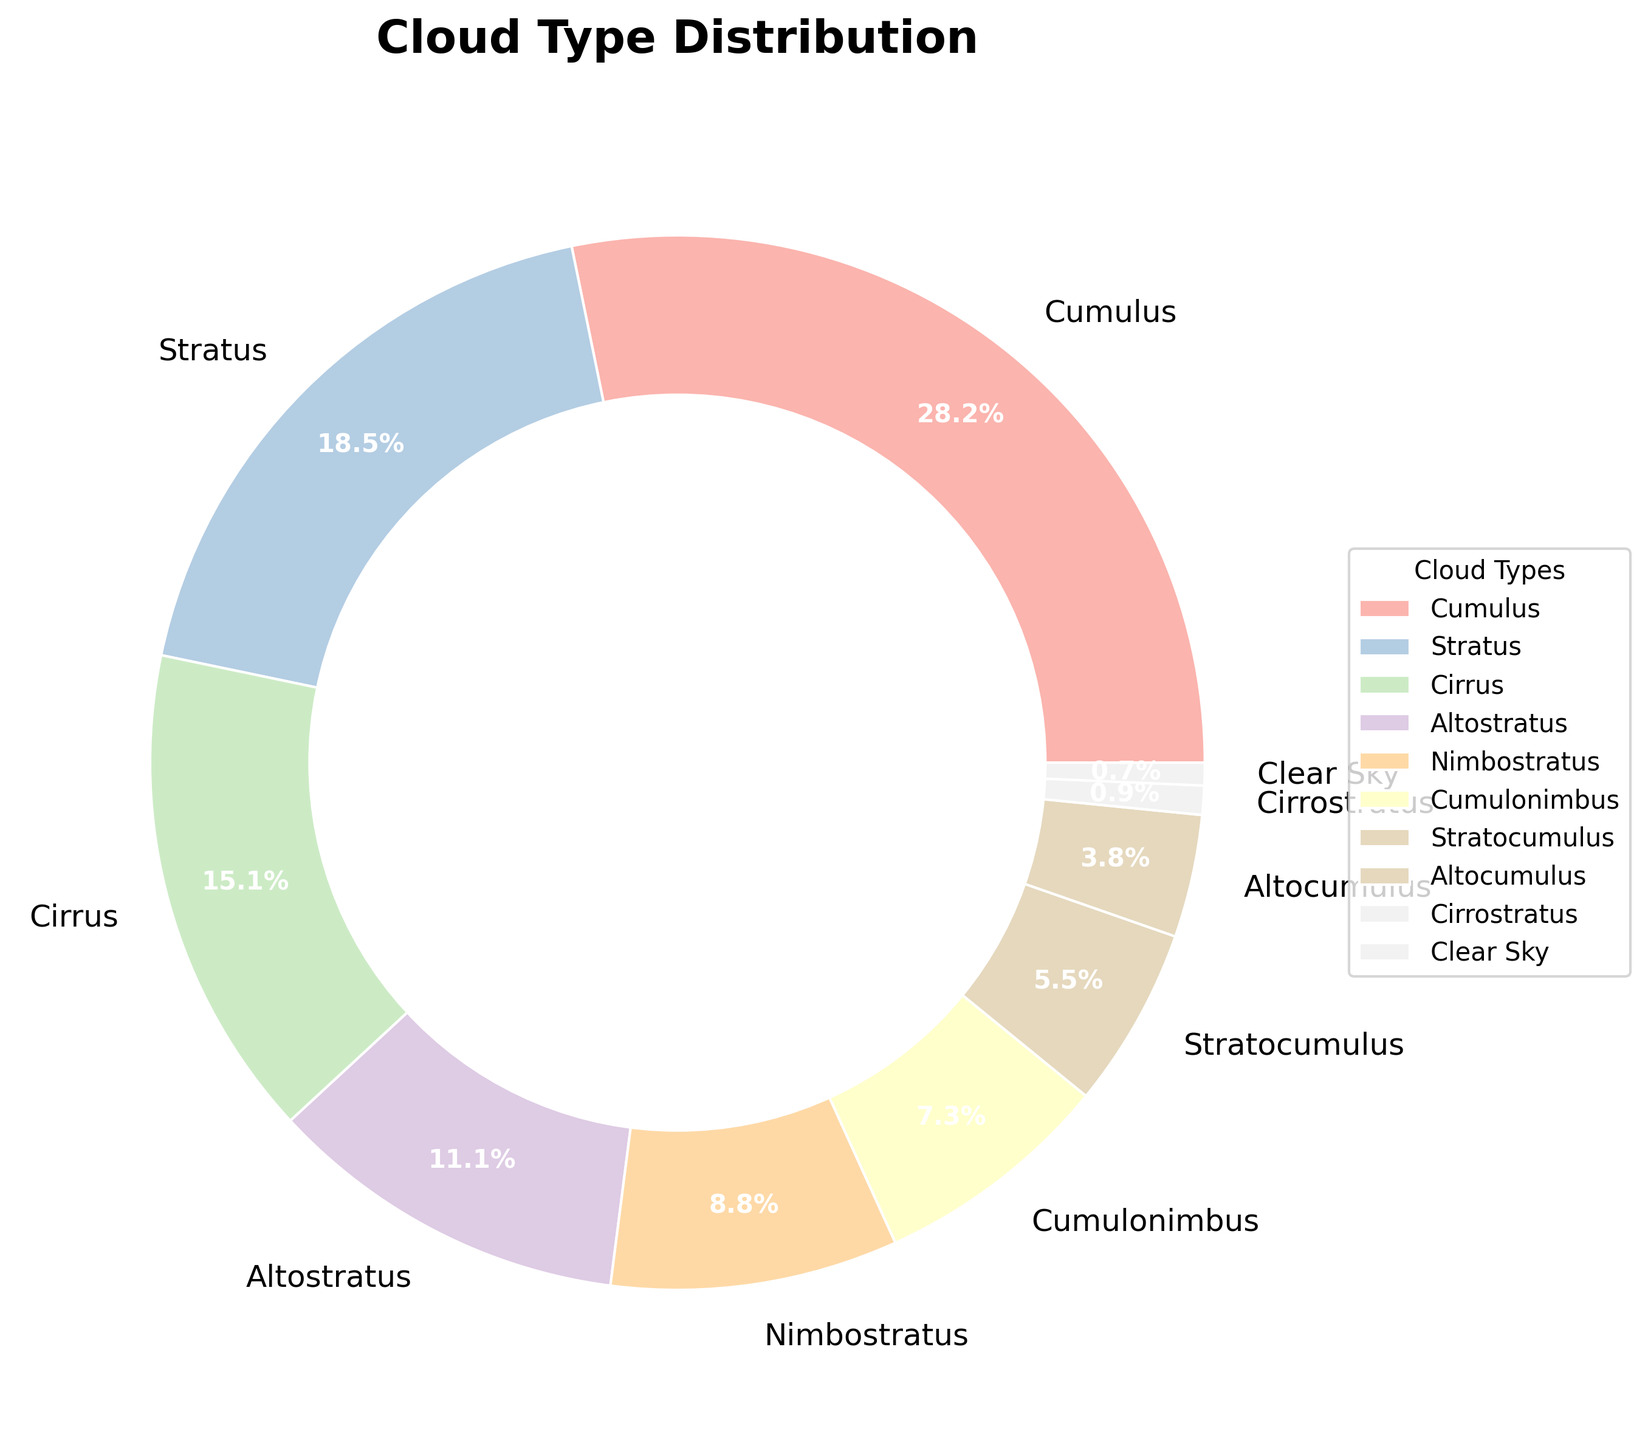What is the most common cloud type observed? By looking at the pie chart, we can see the largest section. The label with the highest percentage is "Cumulus" at 28.5%.
Answer: Cumulus Which cloud types comprise less than 10% each? From the chart, we can identify sections that are smaller than 10% by their corresponding labels. These are Nimbostratus (8.9%), Cumulonimbus (7.4%), Stratocumulus (5.6%), Altocumulus (3.8%), Cirrostratus (0.9%), and Clear Sky (0.7%).
Answer: Nimbostratus, Cumulonimbus, Stratocumulus, Altocumulus, Cirrostratus, Clear Sky How much more prevalent is Cumulus compared to Stratus clouds? Cumulus is at 28.5%, whereas Stratus is at 18.7%. The difference is calculated as 28.5% - 18.7%, which gives us 9.8%.
Answer: 9.8% Which cloud type is the least common, and what is its percentage? The smallest section in the pie chart is "Clear Sky," which has a percentage of 0.7%.
Answer: Clear Sky, 0.7% Are there more Altostratus or Altocumulus clouds observed? By comparing the two sections labeled Altostratus and Altocumulus, Altostratus is at 11.2%, while Altocumulus is at 3.8%. Therefore, Altostratus is more prevalent.
Answer: Altostratus What is the combined percentage of Cumulonimbus and Stratocumulus cloud types? Adding the percentages of Cumulonimbus and Stratocumulus gives us 7.4% + 5.6%, resulting in 13%.
Answer: 13% Approximately how much more prevalent are Cumulus clouds than the combination of Cirrostratus and Clear Sky? Cumulus clouds are 28.5%. Cirrostratus is 0.9%, and Clear Sky is 0.7%. The sum of Cirrostratus and Clear Sky is 0.9% + 0.7% = 1.6%. The difference between Cumulus and this combination is 28.5% - 1.6% = 26.9%.
Answer: 26.9% Which cloud type observed has the closest percentage to 20%? By checking the chart, Stratus is the closest to 20% with a value of 18.7%.
Answer: Stratus How many cloud types were observed more frequently than Altostratus? Altostratus is at 11.2%. By checking the chart, Cumulus, Stratus, and Cirrus have percentages higher than Altostratus. Therefore, there are three cloud types more frequent than Altostratus.
Answer: Three 